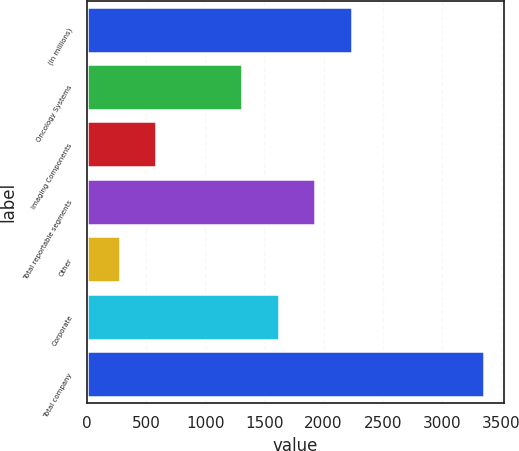Convert chart to OTSL. <chart><loc_0><loc_0><loc_500><loc_500><bar_chart><fcel>(In millions)<fcel>Oncology Systems<fcel>Imaging Components<fcel>Total reportable segments<fcel>Other<fcel>Corporate<fcel>Total company<nl><fcel>2237.71<fcel>1314.1<fcel>586.47<fcel>1929.84<fcel>278.6<fcel>1621.97<fcel>3357.3<nl></chart> 